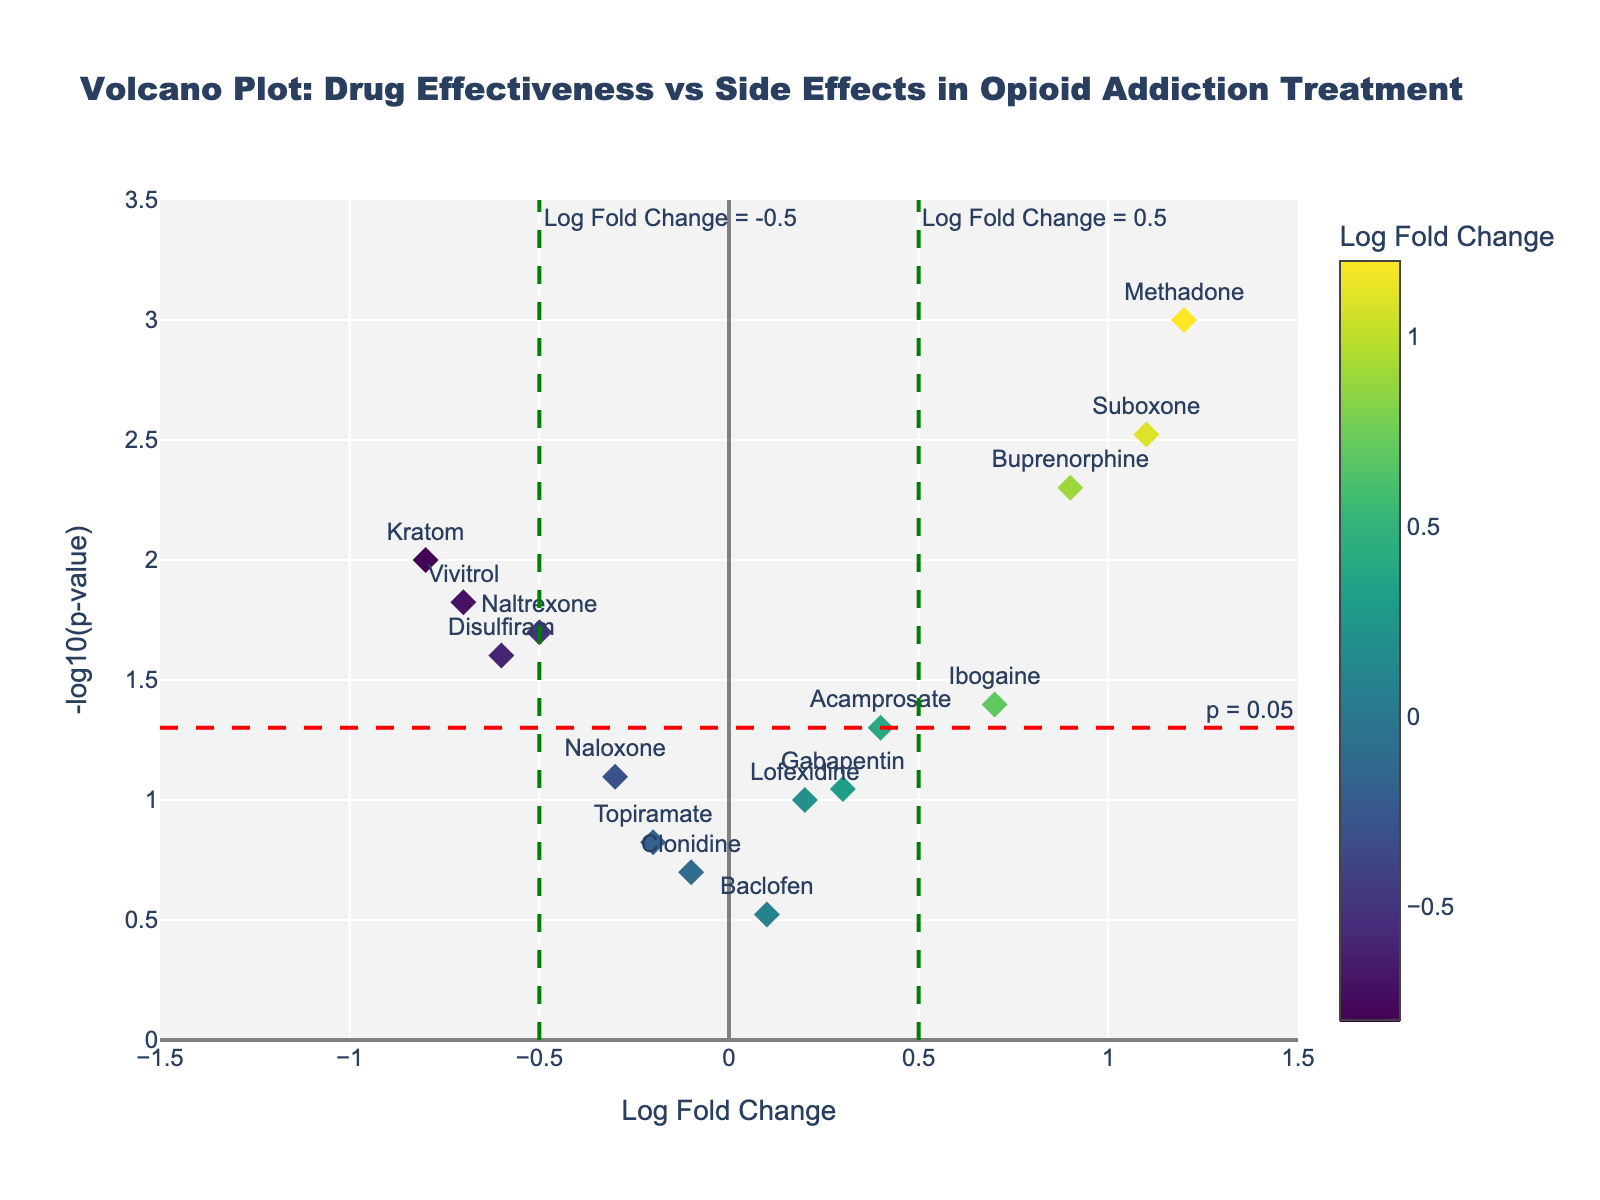What is the title of the figure? Look for the largest text, typically at the top of the plot, which describes the main theme or topic being displayed.
Answer: Volcano Plot: Drug Effectiveness vs Side Effects in Opioid Addiction Treatment How many drugs have a log fold change greater than 0.5? Identify the data points on the x-axis that are greater than 0.5. The drugs with these values are Methadone, Buprenorphine, Suboxone, Ibogaine, totaling 4.
Answer: 4 Which drug has the highest -log10(p-value)? Look for the data point with the maximum value on the y-axis. Methadone has the highest -log10(p-value).
Answer: Methadone Are there any drugs that have a log fold change less than -0.5 and a p-value less than 0.05? Locate points with a log fold change less than -0.5 (left side of the x-axis) and also greater than 1.3 on the y-axis threshold which means -log10(0.05). Kratom is the drug falling in this category.
Answer: Kratom What is the log fold change and p-value for Vivitrol? Find Vivitrol on the plot and read off the coordinates. Vivitrol has a log fold change of -0.7 and a p-value of 0.015.
Answer: -0.7, 0.015 Which drugs show statistically significant effectiveness (p < 0.05) but have a negative log fold change? Look for data points above the red horizontal line (p < 0.05) and on the left side (negative log fold change). The drugs are Naltrexone, Vivitrol, Disulfiram, Kratom.
Answer: Naltrexone, Vivitrol, Disulfiram, Kratom What is the significance threshold for the p-value in the plot? Identify the horizontal red dashed line on the plot which denotes the threshold value. It's labeled at -log10(p-value). The threshold is -log10(0.05).
Answer: 0.05 Which drugs have both log fold change greater than 0.5 and p-value less than 0.05? Locate points to the right of the green vertical line (0.5) and above the red horizontal line (-log10(0.05)). The drugs are Methadone, Buprenorphine, Suboxone.
Answer: Methadone, Buprenorphine, Suboxone How does the drug Ibogaine fare in terms of log fold change and significance? Find Ibogaine and notice its position with respect to the axes. Ibogaine has a log fold change of 0.7 and is above meaning p-value is greater than 0.05 but less significant as compared to others.
Answer: 0.7, less significant 